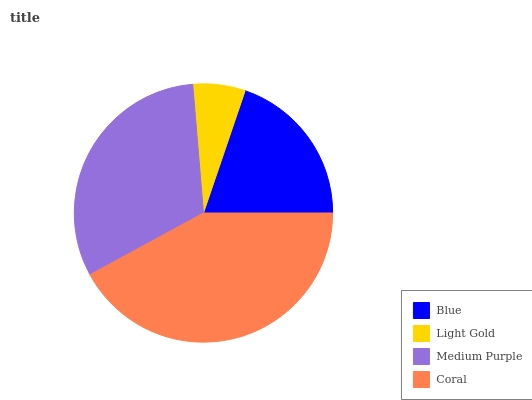Is Light Gold the minimum?
Answer yes or no. Yes. Is Coral the maximum?
Answer yes or no. Yes. Is Medium Purple the minimum?
Answer yes or no. No. Is Medium Purple the maximum?
Answer yes or no. No. Is Medium Purple greater than Light Gold?
Answer yes or no. Yes. Is Light Gold less than Medium Purple?
Answer yes or no. Yes. Is Light Gold greater than Medium Purple?
Answer yes or no. No. Is Medium Purple less than Light Gold?
Answer yes or no. No. Is Medium Purple the high median?
Answer yes or no. Yes. Is Blue the low median?
Answer yes or no. Yes. Is Coral the high median?
Answer yes or no. No. Is Light Gold the low median?
Answer yes or no. No. 